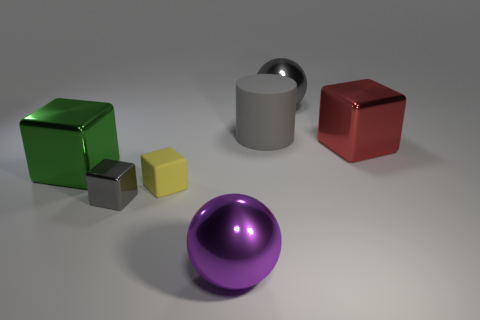How many other things are the same material as the red thing?
Your response must be concise. 4. How many brown objects are cylinders or large shiny balls?
Ensure brevity in your answer.  0. There is a block that is the same color as the rubber cylinder; what is its size?
Your answer should be compact. Small. There is a yellow rubber thing; what number of shiny cubes are behind it?
Provide a succinct answer. 2. There is a gray shiny object that is behind the big shiny cube that is to the left of the gray metal thing that is behind the big green metal object; what size is it?
Provide a short and direct response. Large. Are there any large gray balls in front of the gray block that is to the right of the large metal object on the left side of the small gray shiny block?
Your answer should be compact. No. Is the number of purple metal spheres greater than the number of tiny purple matte cubes?
Give a very brief answer. Yes. The rubber object that is behind the large red thing is what color?
Offer a terse response. Gray. Is the number of large green things that are to the left of the big red block greater than the number of small purple matte objects?
Provide a succinct answer. Yes. Does the yellow object have the same material as the green cube?
Make the answer very short. No. 